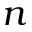Convert formula to latex. <formula><loc_0><loc_0><loc_500><loc_500>n</formula> 